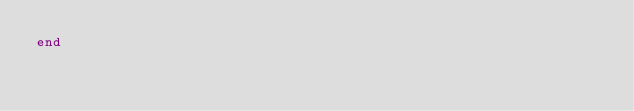<code> <loc_0><loc_0><loc_500><loc_500><_Ruby_>end
</code> 